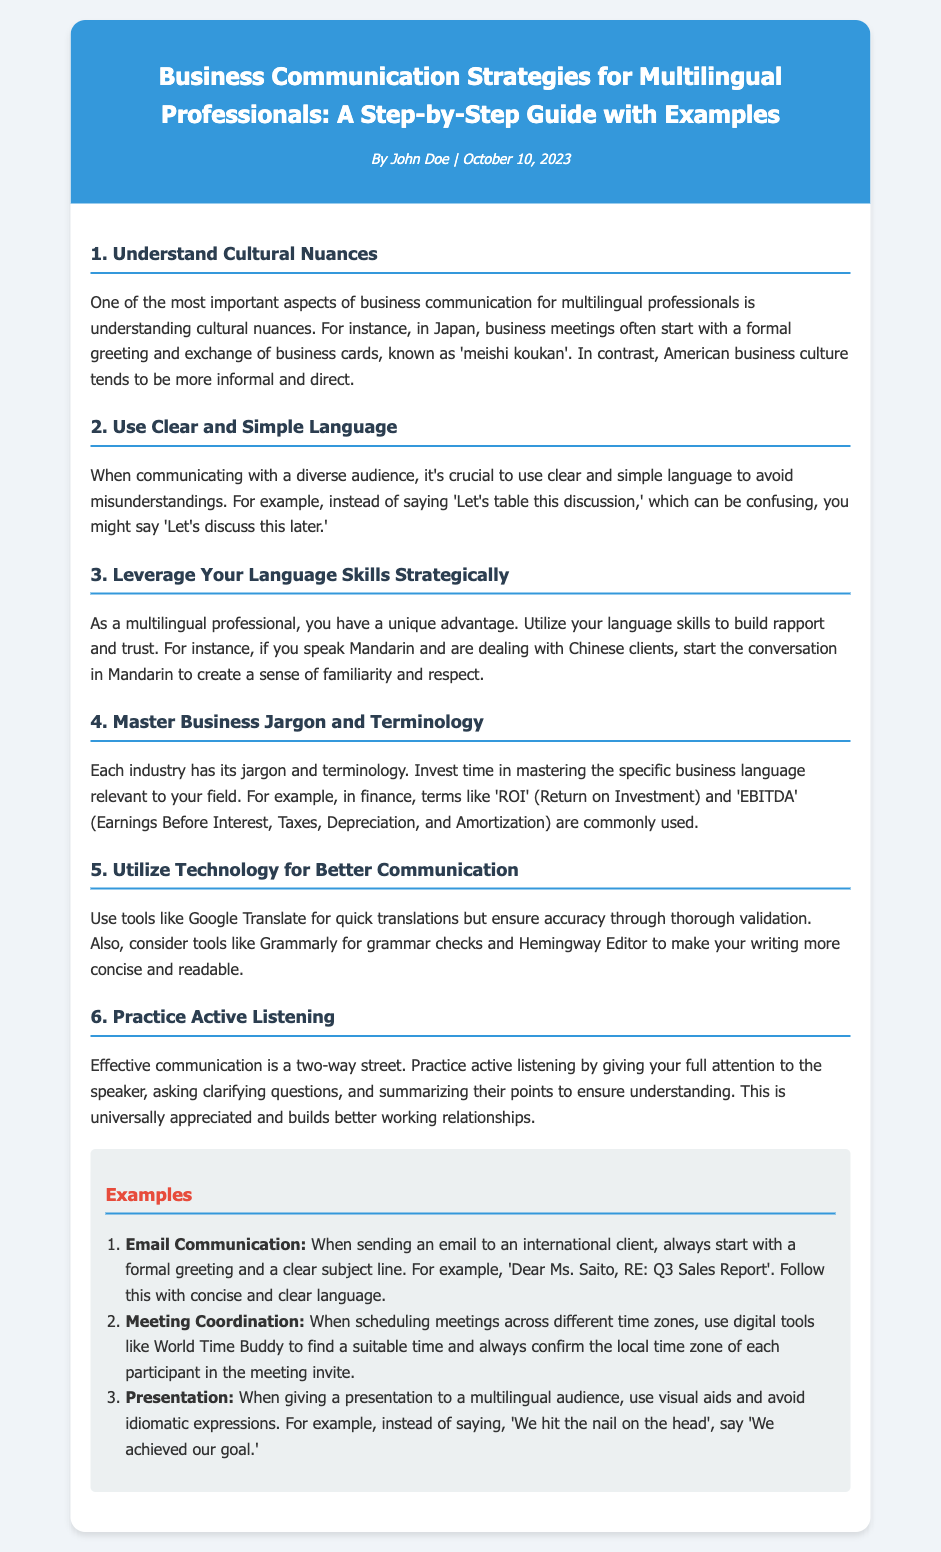What is the title of the document? The title is stated at the top of the document under the recipe header.
Answer: Business Communication Strategies for Multilingual Professionals: A Step-by-Step Guide with Examples Who is the author of the document? The author is presented in the header along with the publication date.
Answer: John Doe When was the document published? The publication date is shown in the recipe meta section.
Answer: October 10, 2023 What is the first strategy mentioned? The first strategy is detailed in the initial recipe section.
Answer: Understand Cultural Nuances How many steps are outlined in the guide? The number of strategies is indicated by the sections listed in the document.
Answer: Six What tool is suggested for grammar checks? This information is found in the section about using technology for better communication.
Answer: Grammarly What should you avoid when giving a presentation to a multilingual audience? This detail is mentioned under the presentation example.
Answer: Idiomatic expressions What industry terminology is specifically mentioned? The document provides examples of industry jargon in the relevant section.
Answer: ROI (Return on Investment) How can you schedule meetings across different time zones effectively? This information is described in the meeting coordination example.
Answer: Use digital tools like World Time Buddy 